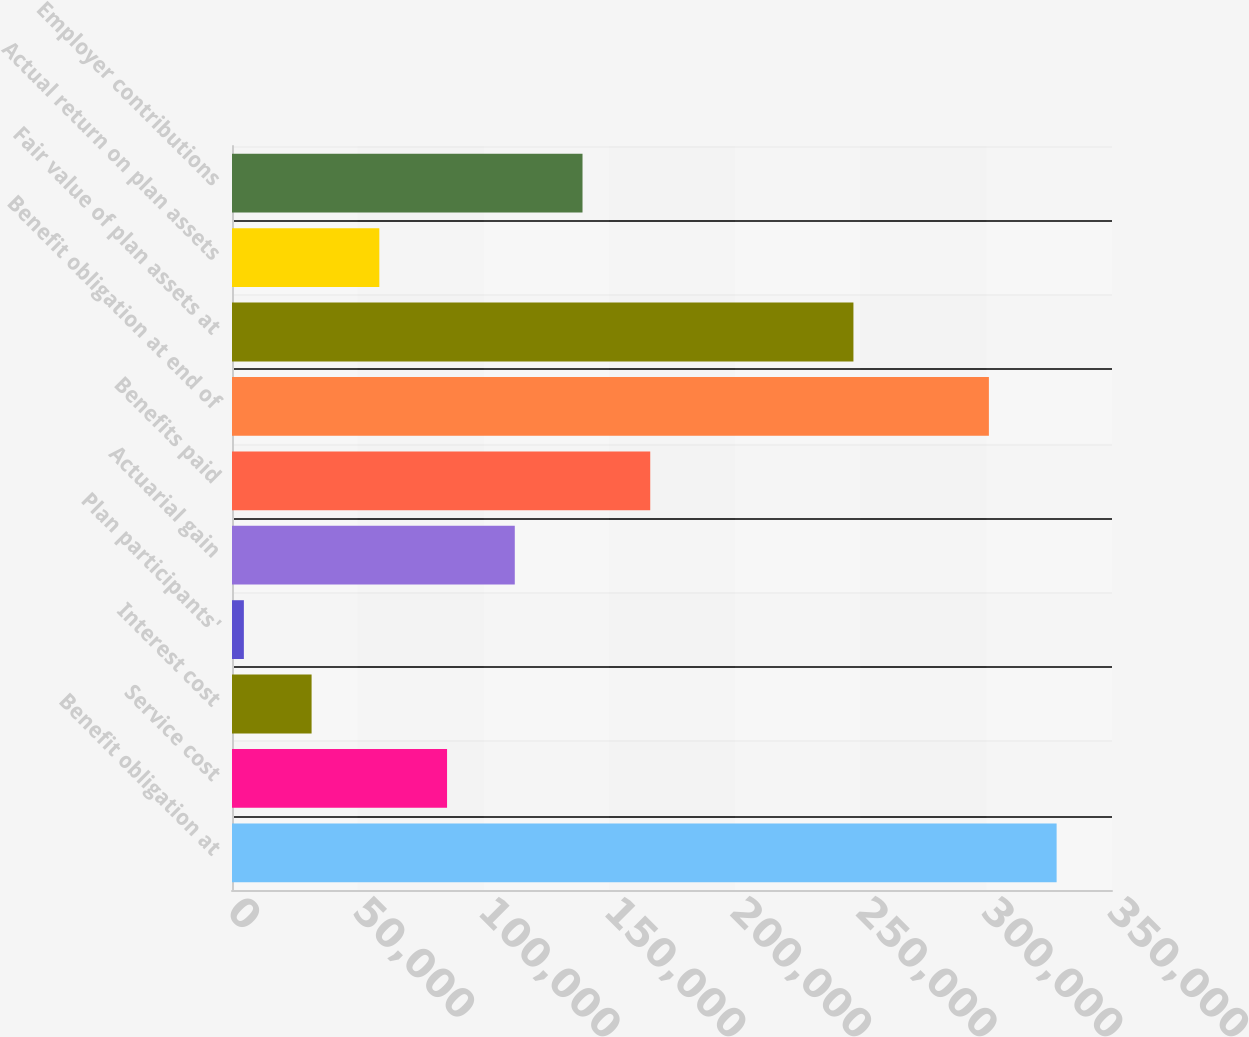<chart> <loc_0><loc_0><loc_500><loc_500><bar_chart><fcel>Benefit obligation at<fcel>Service cost<fcel>Interest cost<fcel>Plan participants'<fcel>Actuarial gain<fcel>Benefits paid<fcel>Benefit obligation at end of<fcel>Fair value of plan assets at<fcel>Actual return on plan assets<fcel>Employer contributions<nl><fcel>327974<fcel>85533.4<fcel>31657.8<fcel>4720<fcel>112471<fcel>166347<fcel>301036<fcel>247160<fcel>58595.6<fcel>139409<nl></chart> 